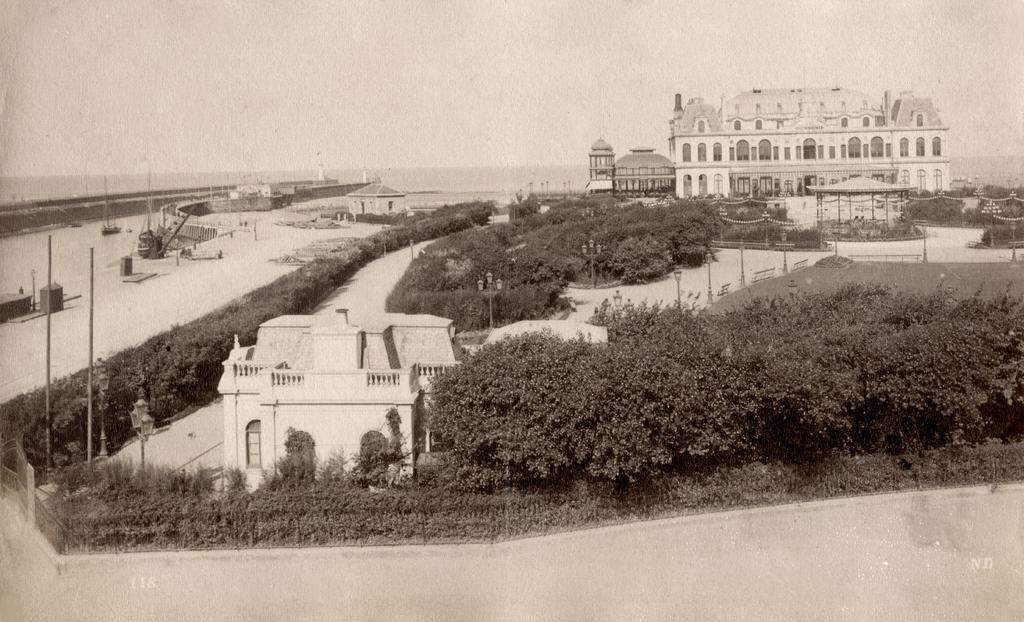What type of structures can be seen in the image? There are buildings in the image. What type of natural elements can be seen in the image? There are trees in the image. What type of man-made objects can be seen in the image? There are poles and lights in the image. What type of vehicles can be seen in the image? There are boats in the image. What other objects can be seen in the image? There are other objects, including a shed, in the image. What is visible in the background of the image? The sky is visible in the background of the image. Where is the calculator located in the image? There is no calculator present in the image. What type of school can be seen in the image? There is no school present in the image. 